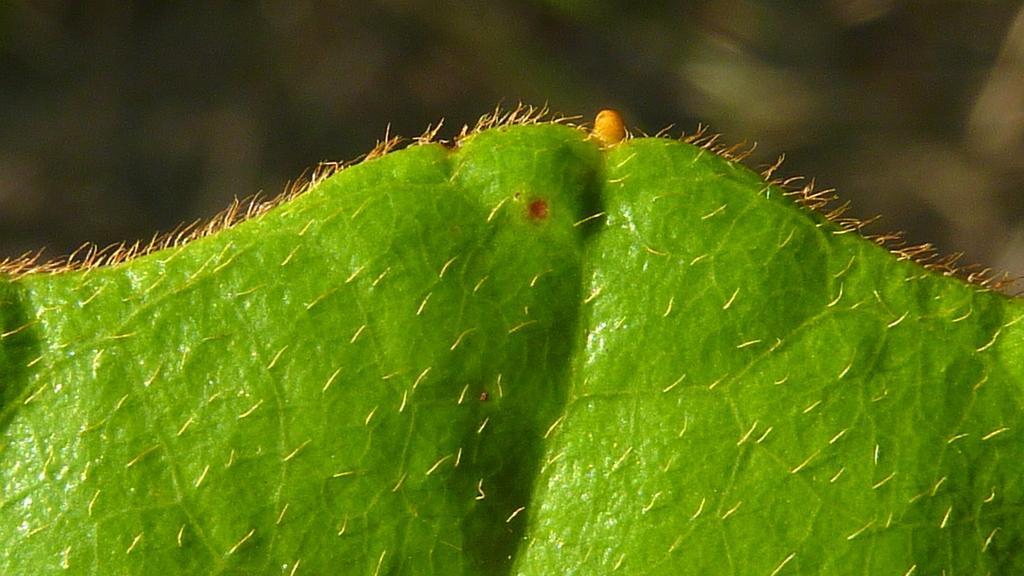Describe this image in one or two sentences. In the picture I can see green leaf which has few yellow color objects on it. 